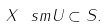<formula> <loc_0><loc_0><loc_500><loc_500>X \ s m U \subset { S } .</formula> 